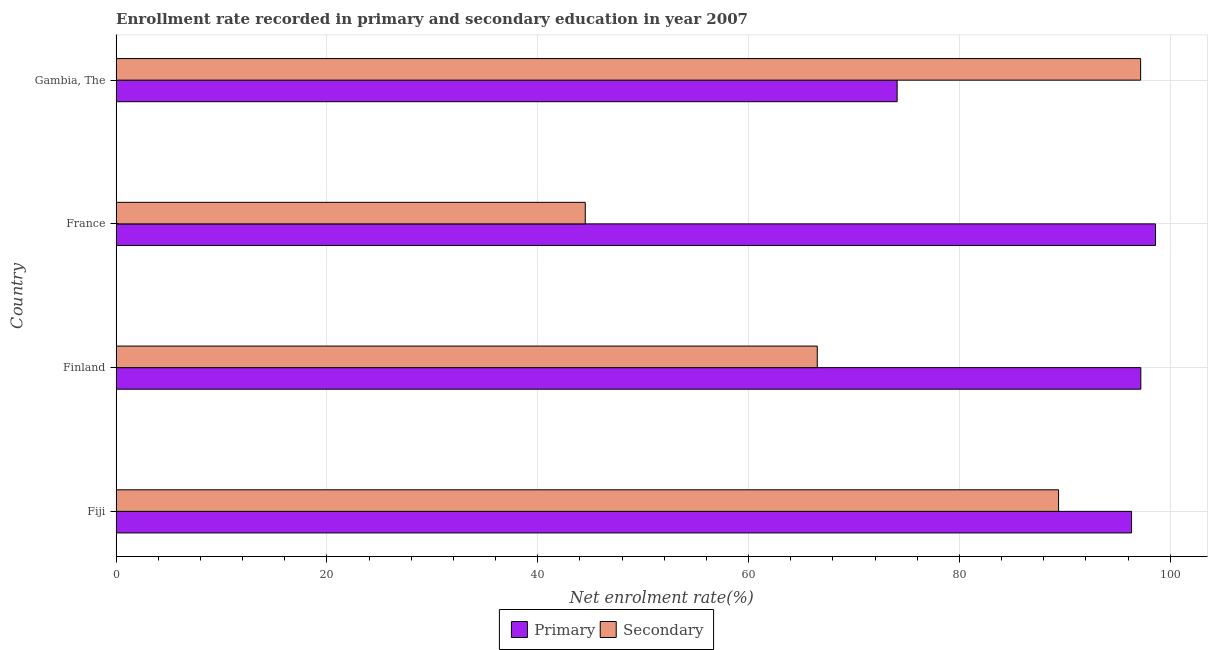Are the number of bars per tick equal to the number of legend labels?
Offer a terse response. Yes. Are the number of bars on each tick of the Y-axis equal?
Provide a short and direct response. Yes. How many bars are there on the 3rd tick from the top?
Provide a succinct answer. 2. How many bars are there on the 3rd tick from the bottom?
Your response must be concise. 2. What is the label of the 3rd group of bars from the top?
Your response must be concise. Finland. What is the enrollment rate in secondary education in Finland?
Your response must be concise. 66.51. Across all countries, what is the maximum enrollment rate in primary education?
Your answer should be very brief. 98.6. Across all countries, what is the minimum enrollment rate in primary education?
Your response must be concise. 74.09. In which country was the enrollment rate in primary education maximum?
Provide a succinct answer. France. In which country was the enrollment rate in secondary education minimum?
Make the answer very short. France. What is the total enrollment rate in primary education in the graph?
Your answer should be very brief. 366.22. What is the difference between the enrollment rate in secondary education in Fiji and that in Gambia, The?
Your answer should be very brief. -7.78. What is the difference between the enrollment rate in secondary education in Finland and the enrollment rate in primary education in Gambia, The?
Offer a very short reply. -7.58. What is the average enrollment rate in secondary education per country?
Offer a terse response. 74.4. What is the difference between the enrollment rate in primary education and enrollment rate in secondary education in France?
Give a very brief answer. 54.1. In how many countries, is the enrollment rate in primary education greater than 20 %?
Your answer should be compact. 4. Is the enrollment rate in primary education in Fiji less than that in Finland?
Your response must be concise. Yes. What is the difference between the highest and the second highest enrollment rate in primary education?
Make the answer very short. 1.39. What is the difference between the highest and the lowest enrollment rate in secondary education?
Your response must be concise. 52.68. In how many countries, is the enrollment rate in secondary education greater than the average enrollment rate in secondary education taken over all countries?
Give a very brief answer. 2. Is the sum of the enrollment rate in primary education in Finland and France greater than the maximum enrollment rate in secondary education across all countries?
Your answer should be compact. Yes. What does the 1st bar from the top in Finland represents?
Offer a very short reply. Secondary. What does the 1st bar from the bottom in Gambia, The represents?
Your response must be concise. Primary. How many bars are there?
Give a very brief answer. 8. Are all the bars in the graph horizontal?
Your answer should be very brief. Yes. How many countries are there in the graph?
Provide a short and direct response. 4. How many legend labels are there?
Provide a short and direct response. 2. How are the legend labels stacked?
Give a very brief answer. Horizontal. What is the title of the graph?
Offer a terse response. Enrollment rate recorded in primary and secondary education in year 2007. Does "Grants" appear as one of the legend labels in the graph?
Offer a terse response. No. What is the label or title of the X-axis?
Provide a short and direct response. Net enrolment rate(%). What is the Net enrolment rate(%) of Primary in Fiji?
Offer a very short reply. 96.33. What is the Net enrolment rate(%) of Secondary in Fiji?
Ensure brevity in your answer.  89.4. What is the Net enrolment rate(%) of Primary in Finland?
Offer a very short reply. 97.21. What is the Net enrolment rate(%) in Secondary in Finland?
Make the answer very short. 66.51. What is the Net enrolment rate(%) in Primary in France?
Offer a very short reply. 98.6. What is the Net enrolment rate(%) of Secondary in France?
Offer a very short reply. 44.5. What is the Net enrolment rate(%) of Primary in Gambia, The?
Keep it short and to the point. 74.09. What is the Net enrolment rate(%) in Secondary in Gambia, The?
Give a very brief answer. 97.19. Across all countries, what is the maximum Net enrolment rate(%) in Primary?
Your answer should be compact. 98.6. Across all countries, what is the maximum Net enrolment rate(%) of Secondary?
Provide a short and direct response. 97.19. Across all countries, what is the minimum Net enrolment rate(%) in Primary?
Provide a short and direct response. 74.09. Across all countries, what is the minimum Net enrolment rate(%) of Secondary?
Make the answer very short. 44.5. What is the total Net enrolment rate(%) of Primary in the graph?
Give a very brief answer. 366.22. What is the total Net enrolment rate(%) of Secondary in the graph?
Your answer should be very brief. 297.61. What is the difference between the Net enrolment rate(%) in Primary in Fiji and that in Finland?
Make the answer very short. -0.88. What is the difference between the Net enrolment rate(%) of Secondary in Fiji and that in Finland?
Provide a short and direct response. 22.89. What is the difference between the Net enrolment rate(%) in Primary in Fiji and that in France?
Provide a succinct answer. -2.27. What is the difference between the Net enrolment rate(%) of Secondary in Fiji and that in France?
Ensure brevity in your answer.  44.9. What is the difference between the Net enrolment rate(%) of Primary in Fiji and that in Gambia, The?
Provide a short and direct response. 22.24. What is the difference between the Net enrolment rate(%) of Secondary in Fiji and that in Gambia, The?
Give a very brief answer. -7.78. What is the difference between the Net enrolment rate(%) in Primary in Finland and that in France?
Your answer should be very brief. -1.39. What is the difference between the Net enrolment rate(%) of Secondary in Finland and that in France?
Provide a short and direct response. 22.01. What is the difference between the Net enrolment rate(%) in Primary in Finland and that in Gambia, The?
Your answer should be compact. 23.12. What is the difference between the Net enrolment rate(%) in Secondary in Finland and that in Gambia, The?
Your answer should be very brief. -30.68. What is the difference between the Net enrolment rate(%) in Primary in France and that in Gambia, The?
Provide a succinct answer. 24.51. What is the difference between the Net enrolment rate(%) of Secondary in France and that in Gambia, The?
Offer a very short reply. -52.68. What is the difference between the Net enrolment rate(%) of Primary in Fiji and the Net enrolment rate(%) of Secondary in Finland?
Keep it short and to the point. 29.81. What is the difference between the Net enrolment rate(%) of Primary in Fiji and the Net enrolment rate(%) of Secondary in France?
Your response must be concise. 51.82. What is the difference between the Net enrolment rate(%) in Primary in Fiji and the Net enrolment rate(%) in Secondary in Gambia, The?
Offer a terse response. -0.86. What is the difference between the Net enrolment rate(%) of Primary in Finland and the Net enrolment rate(%) of Secondary in France?
Offer a very short reply. 52.7. What is the difference between the Net enrolment rate(%) in Primary in Finland and the Net enrolment rate(%) in Secondary in Gambia, The?
Provide a succinct answer. 0.02. What is the difference between the Net enrolment rate(%) of Primary in France and the Net enrolment rate(%) of Secondary in Gambia, The?
Give a very brief answer. 1.41. What is the average Net enrolment rate(%) in Primary per country?
Offer a very short reply. 91.56. What is the average Net enrolment rate(%) of Secondary per country?
Ensure brevity in your answer.  74.4. What is the difference between the Net enrolment rate(%) of Primary and Net enrolment rate(%) of Secondary in Fiji?
Make the answer very short. 6.92. What is the difference between the Net enrolment rate(%) in Primary and Net enrolment rate(%) in Secondary in Finland?
Your answer should be compact. 30.69. What is the difference between the Net enrolment rate(%) of Primary and Net enrolment rate(%) of Secondary in France?
Keep it short and to the point. 54.1. What is the difference between the Net enrolment rate(%) of Primary and Net enrolment rate(%) of Secondary in Gambia, The?
Keep it short and to the point. -23.1. What is the ratio of the Net enrolment rate(%) in Primary in Fiji to that in Finland?
Your answer should be very brief. 0.99. What is the ratio of the Net enrolment rate(%) of Secondary in Fiji to that in Finland?
Provide a short and direct response. 1.34. What is the ratio of the Net enrolment rate(%) of Primary in Fiji to that in France?
Provide a short and direct response. 0.98. What is the ratio of the Net enrolment rate(%) of Secondary in Fiji to that in France?
Make the answer very short. 2.01. What is the ratio of the Net enrolment rate(%) of Primary in Fiji to that in Gambia, The?
Ensure brevity in your answer.  1.3. What is the ratio of the Net enrolment rate(%) in Secondary in Fiji to that in Gambia, The?
Ensure brevity in your answer.  0.92. What is the ratio of the Net enrolment rate(%) in Primary in Finland to that in France?
Your answer should be compact. 0.99. What is the ratio of the Net enrolment rate(%) in Secondary in Finland to that in France?
Keep it short and to the point. 1.49. What is the ratio of the Net enrolment rate(%) in Primary in Finland to that in Gambia, The?
Provide a short and direct response. 1.31. What is the ratio of the Net enrolment rate(%) of Secondary in Finland to that in Gambia, The?
Give a very brief answer. 0.68. What is the ratio of the Net enrolment rate(%) in Primary in France to that in Gambia, The?
Make the answer very short. 1.33. What is the ratio of the Net enrolment rate(%) in Secondary in France to that in Gambia, The?
Provide a short and direct response. 0.46. What is the difference between the highest and the second highest Net enrolment rate(%) of Primary?
Make the answer very short. 1.39. What is the difference between the highest and the second highest Net enrolment rate(%) in Secondary?
Ensure brevity in your answer.  7.78. What is the difference between the highest and the lowest Net enrolment rate(%) in Primary?
Ensure brevity in your answer.  24.51. What is the difference between the highest and the lowest Net enrolment rate(%) of Secondary?
Your answer should be very brief. 52.68. 